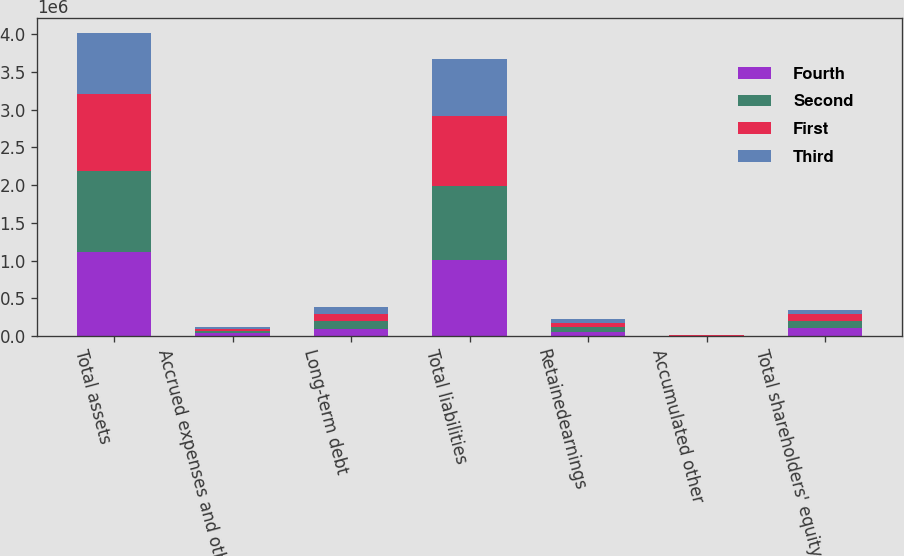Convert chart to OTSL. <chart><loc_0><loc_0><loc_500><loc_500><stacked_bar_chart><ecel><fcel>Total assets<fcel>Accrued expenses and other<fcel>Long-term debt<fcel>Total liabilities<fcel>Retainedearnings<fcel>Accumulated other<fcel>Total shareholders' equity<nl><fcel>Fourth<fcel>1.11046e+06<fcel>41243<fcel>98078<fcel>1.01081e+06<fcel>58006<fcel>2587<fcel>99645<nl><fcel>Second<fcel>1.07283e+06<fcel>28851<fcel>100586<fcel>974818<fcel>55979<fcel>2669<fcel>98011<nl><fcel>First<fcel>1.02473e+06<fcel>28682<fcel>98319<fcel>928910<fcel>54030<fcel>3862<fcel>95821<nl><fcel>Third<fcel>799974<fcel>18635<fcel>81231<fcel>751198<fcel>51808<fcel>2743<fcel>48776<nl></chart> 